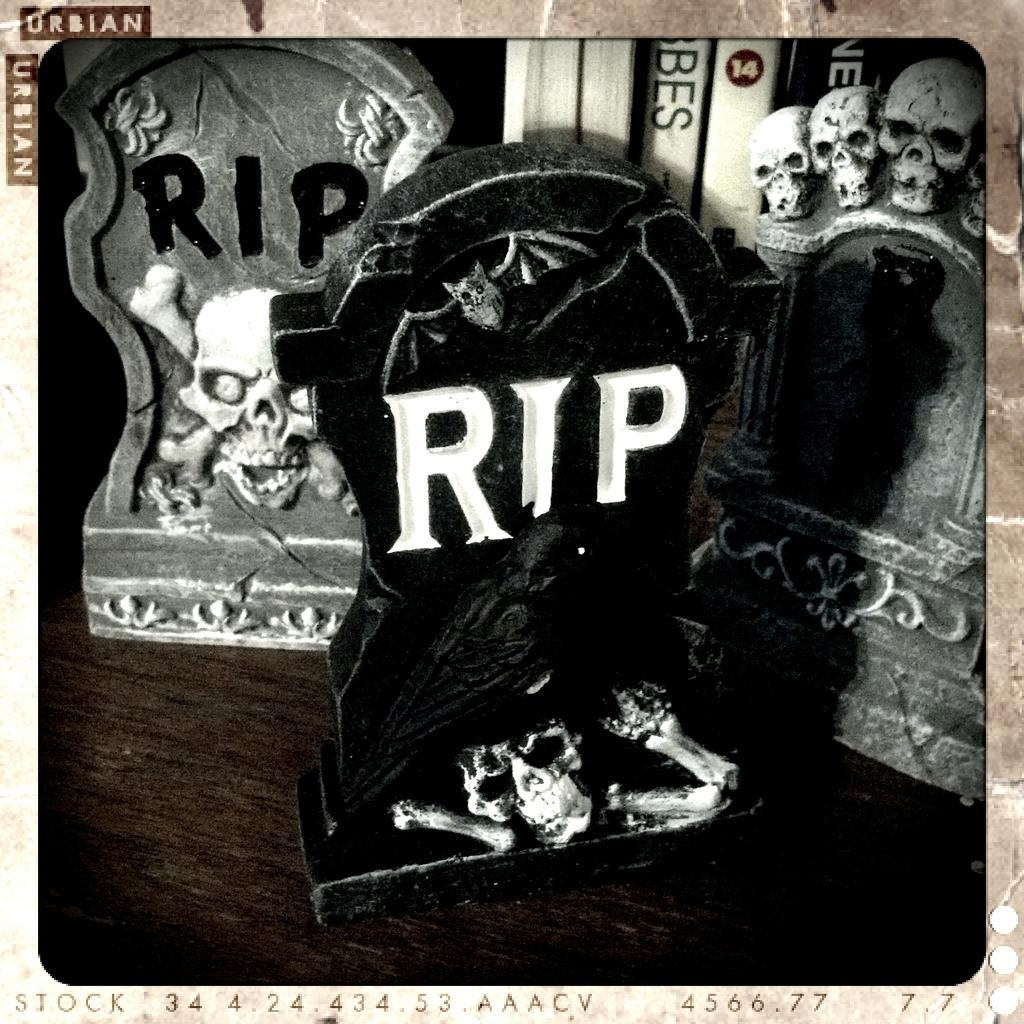<image>
Summarize the visual content of the image. A few scary items including skills and RIP graves. 